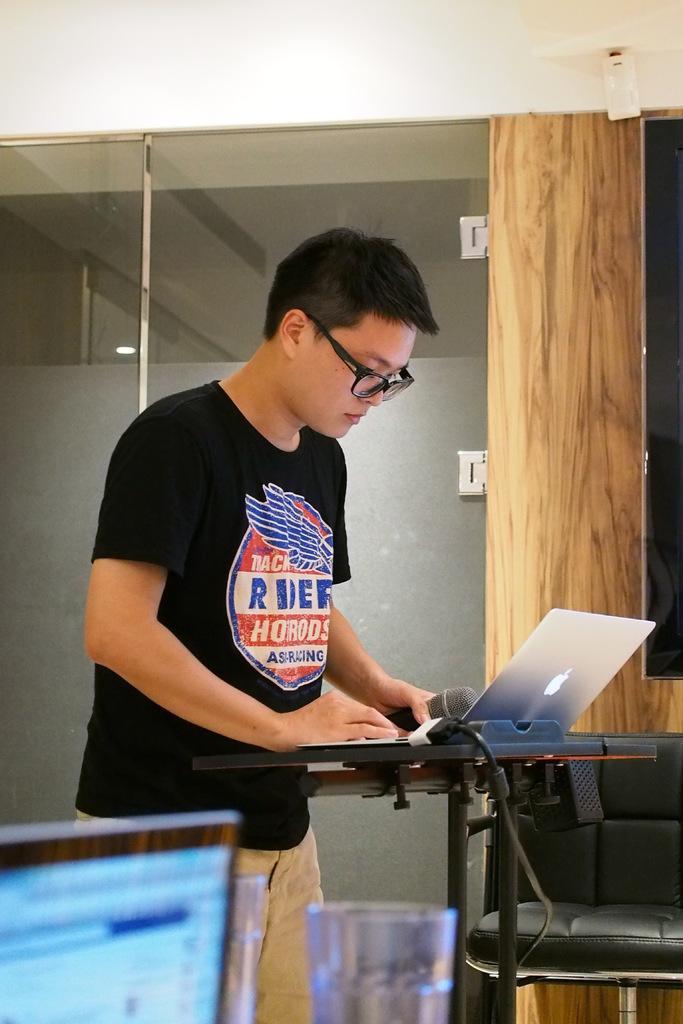In one or two sentences, can you explain what this image depicts? In this image I can see a person standing in a room. He is wearing spectacles, black t shirt and trousers. He is operating a laptop and holding a microphone in his hand. There is a glass and a screen in the front. There is a black chair and glass door at the back. 